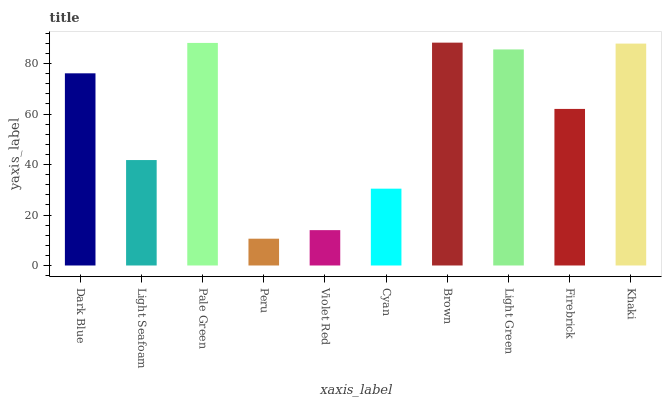Is Peru the minimum?
Answer yes or no. Yes. Is Brown the maximum?
Answer yes or no. Yes. Is Light Seafoam the minimum?
Answer yes or no. No. Is Light Seafoam the maximum?
Answer yes or no. No. Is Dark Blue greater than Light Seafoam?
Answer yes or no. Yes. Is Light Seafoam less than Dark Blue?
Answer yes or no. Yes. Is Light Seafoam greater than Dark Blue?
Answer yes or no. No. Is Dark Blue less than Light Seafoam?
Answer yes or no. No. Is Dark Blue the high median?
Answer yes or no. Yes. Is Firebrick the low median?
Answer yes or no. Yes. Is Brown the high median?
Answer yes or no. No. Is Khaki the low median?
Answer yes or no. No. 